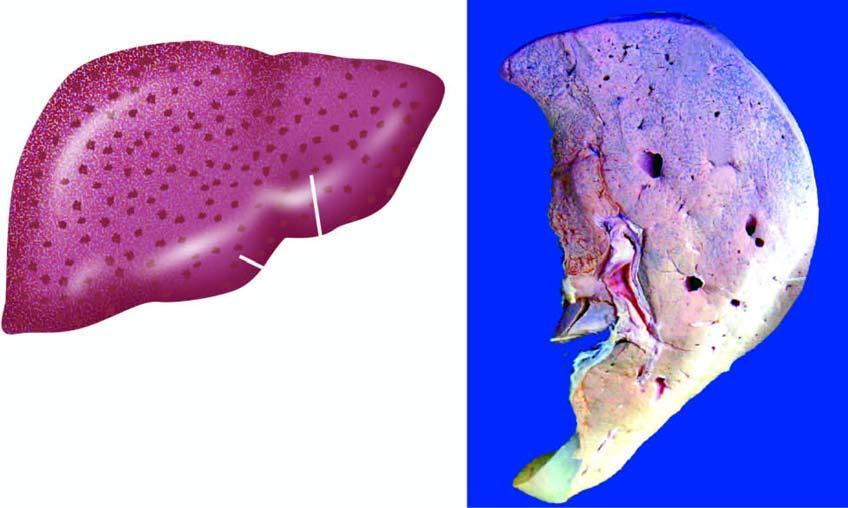what shows mottled appearance-alternate pattern of dark congestion and pale fatty change?
Answer the question using a single word or phrase. The cut surface 